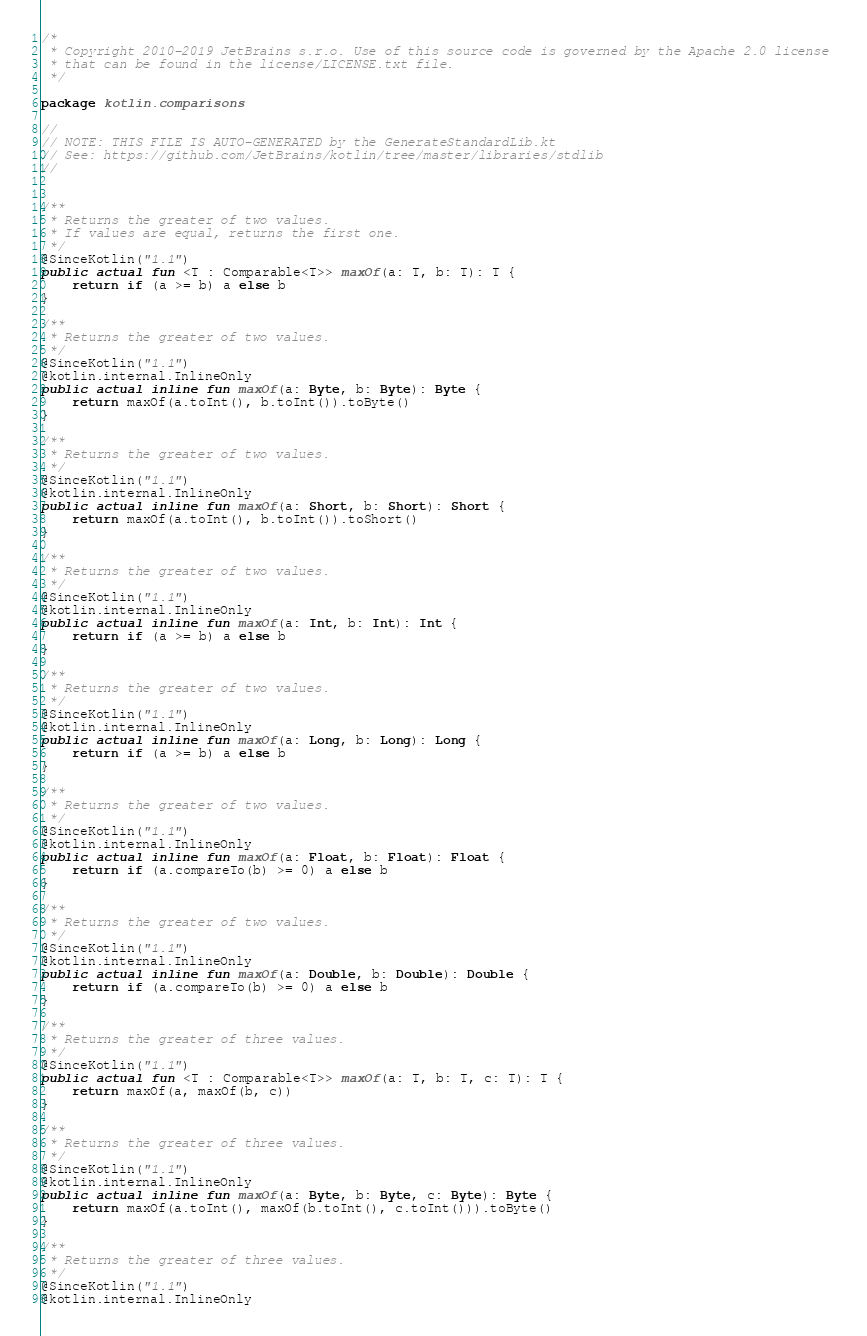<code> <loc_0><loc_0><loc_500><loc_500><_Kotlin_>/*
 * Copyright 2010-2019 JetBrains s.r.o. Use of this source code is governed by the Apache 2.0 license 
 * that can be found in the license/LICENSE.txt file.
 */

package kotlin.comparisons

//
// NOTE: THIS FILE IS AUTO-GENERATED by the GenerateStandardLib.kt
// See: https://github.com/JetBrains/kotlin/tree/master/libraries/stdlib
//


/**
 * Returns the greater of two values.
 * If values are equal, returns the first one.
 */
@SinceKotlin("1.1")
public actual fun <T : Comparable<T>> maxOf(a: T, b: T): T {
    return if (a >= b) a else b
}

/**
 * Returns the greater of two values.
 */
@SinceKotlin("1.1")
@kotlin.internal.InlineOnly
public actual inline fun maxOf(a: Byte, b: Byte): Byte {
    return maxOf(a.toInt(), b.toInt()).toByte()
}

/**
 * Returns the greater of two values.
 */
@SinceKotlin("1.1")
@kotlin.internal.InlineOnly
public actual inline fun maxOf(a: Short, b: Short): Short {
    return maxOf(a.toInt(), b.toInt()).toShort()
}

/**
 * Returns the greater of two values.
 */
@SinceKotlin("1.1")
@kotlin.internal.InlineOnly
public actual inline fun maxOf(a: Int, b: Int): Int {
    return if (a >= b) a else b
}

/**
 * Returns the greater of two values.
 */
@SinceKotlin("1.1")
@kotlin.internal.InlineOnly
public actual inline fun maxOf(a: Long, b: Long): Long {
    return if (a >= b) a else b
}

/**
 * Returns the greater of two values.
 */
@SinceKotlin("1.1")
@kotlin.internal.InlineOnly
public actual inline fun maxOf(a: Float, b: Float): Float {
    return if (a.compareTo(b) >= 0) a else b
}

/**
 * Returns the greater of two values.
 */
@SinceKotlin("1.1")
@kotlin.internal.InlineOnly
public actual inline fun maxOf(a: Double, b: Double): Double {
    return if (a.compareTo(b) >= 0) a else b
}

/**
 * Returns the greater of three values.
 */
@SinceKotlin("1.1")
public actual fun <T : Comparable<T>> maxOf(a: T, b: T, c: T): T {
    return maxOf(a, maxOf(b, c))
}

/**
 * Returns the greater of three values.
 */
@SinceKotlin("1.1")
@kotlin.internal.InlineOnly
public actual inline fun maxOf(a: Byte, b: Byte, c: Byte): Byte {
    return maxOf(a.toInt(), maxOf(b.toInt(), c.toInt())).toByte()
}

/**
 * Returns the greater of three values.
 */
@SinceKotlin("1.1")
@kotlin.internal.InlineOnly</code> 